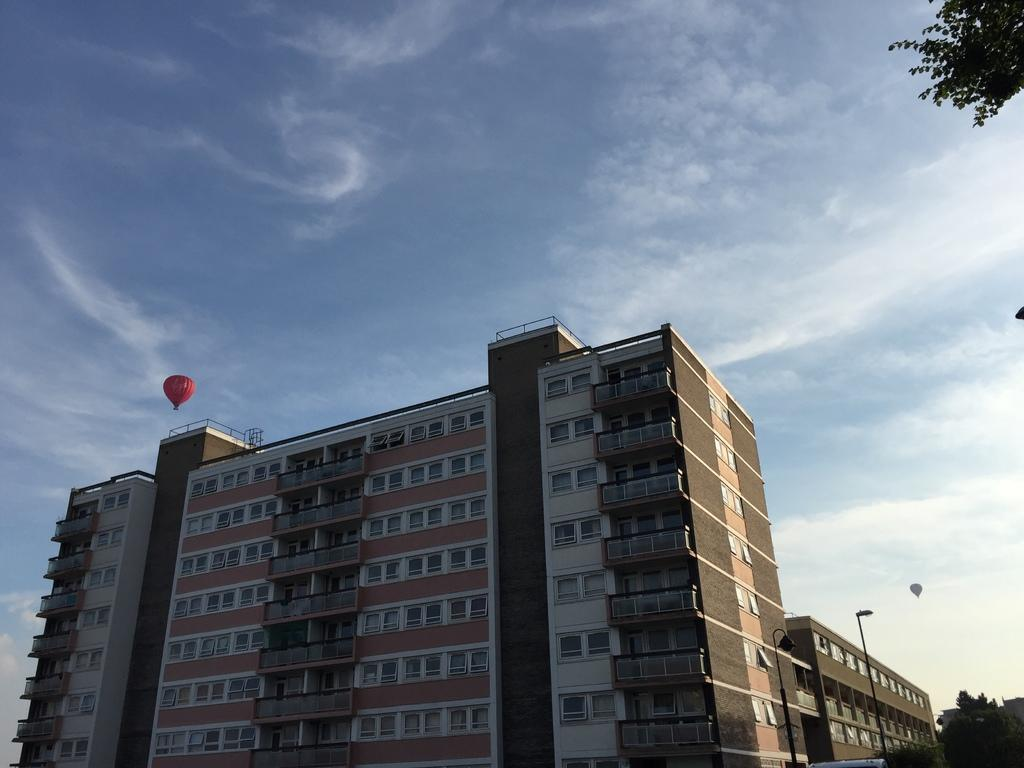What type of structures can be seen in the image? There are buildings in the image. What other natural elements are present in the image? There are trees in the image. What are the tall, thin objects in the image? There are poles in the image. What are the colorful objects floating in the sky? There are parachutes in the image. What can be seen in the background of the image? The sky is visible in the background of the image. What type of cough medicine is visible in the image? There is no cough medicine present in the image. Can you see a baby playing in the image? There is no baby present in the image. 